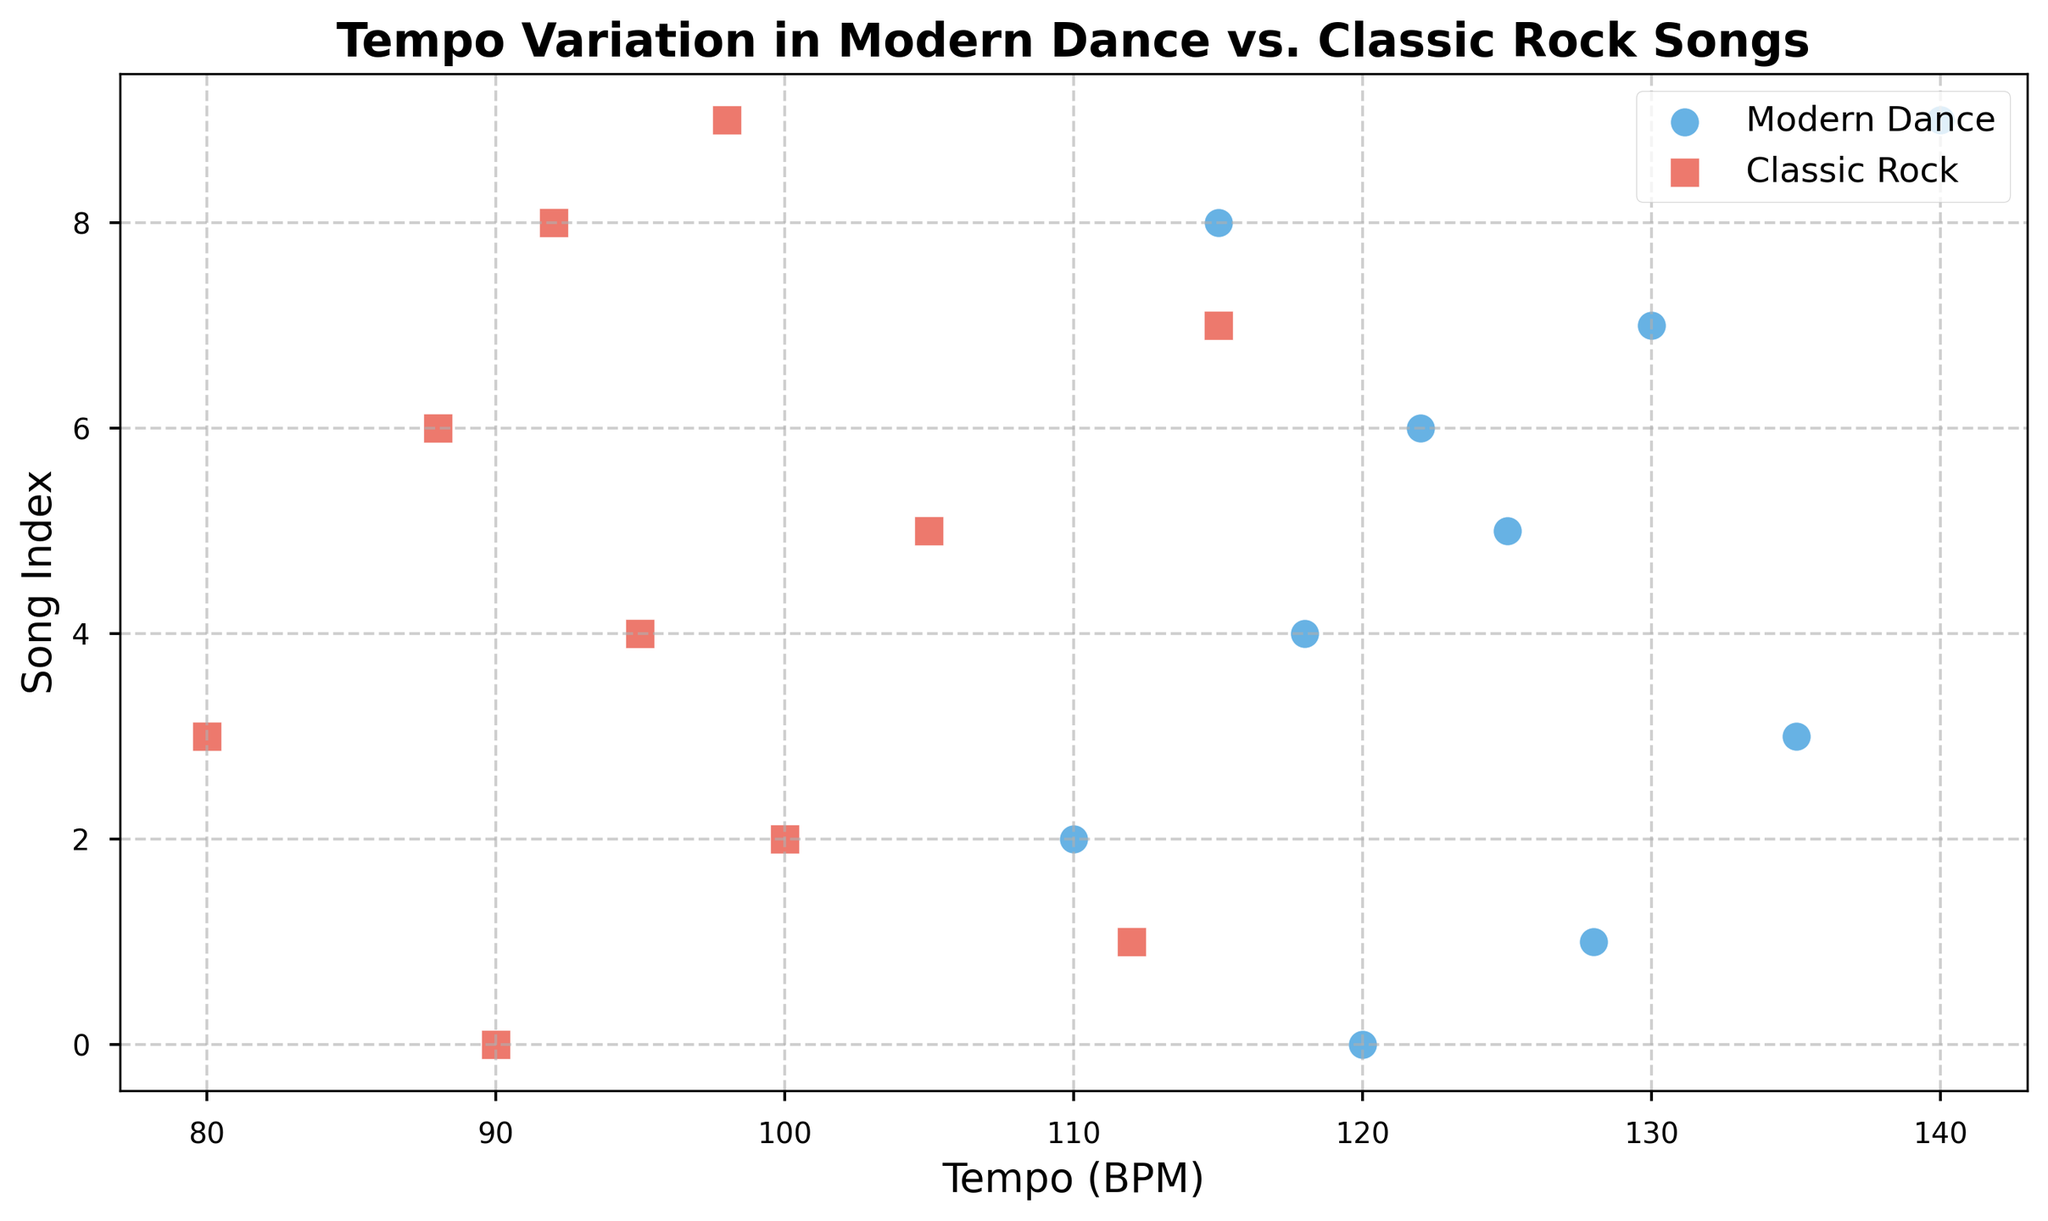What is the highest tempo value in Modern Dance songs? To find the highest tempo value in Modern Dance songs, look at the scattered dots labeled "Modern Dance" and identify the maximum value along the Tempo (BPM) axis.
Answer: 140 What is the average tempo of Classic Rock songs? Sum all the tempo values of Classic Rock songs and divide by the total number of Classic Rock songs: (90 + 112 + 100 + 80 + 95 + 105 + 88 + 115 + 92 + 98) / 10 = 97.5
Answer: 97.5 Which genre has a wider tempo range? Calculate the range (maximum - minimum) for both genres: Modern Dance (140 - 110 = 30) and Classic Rock (115 - 80 = 35). Compare the two ranges.
Answer: Classic Rock What is the tempo difference between the fastest Modern Dance song and the fastest Classic Rock song? Identify the maximum tempo values for both genres: 140 for Modern Dance and 115 for Classic Rock. Subtract the maximum tempo of Classic Rock from that of Modern Dance: 140 - 115.
Answer: 25 How many Modern Dance songs have a tempo higher than 125 BPM? Count the number of dots for Modern Dance songs that are above 125 BPM on the Tempo (BPM) axis (128, 135, 130, 140).
Answer: 4 Which genre has the slowest tempo song? Compare the minimum tempo values of both genres: 110 for Modern Dance and 80 for Classic Rock.
Answer: Classic Rock What is the median tempo of Modern Dance songs? Arrange the tempo values of Modern Dance songs in ascending order, then find the middle value. Tempo values: 110, 115, 118, 120, 122, 125, 128, 130, 135, 140. The median of these 10 values lies between 122 and 125, giving us (122 + 125) / 2.
Answer: 123.5 Which genre has more varied tempo, looking at visual scatter placement? Look at how scattered and spread out the points are for each genre. Classic Rock points are more spread out compared to Modern Dance points. This suggests more variation in tempo.
Answer: Classic Rock How many Classic Rock songs have a tempo below 100 BPM? Count the number of dots for Classic Rock songs that are below 100 BPM on the Tempo (BPM) axis (90, 80, 95, 88, 92, 98).
Answer: 6 